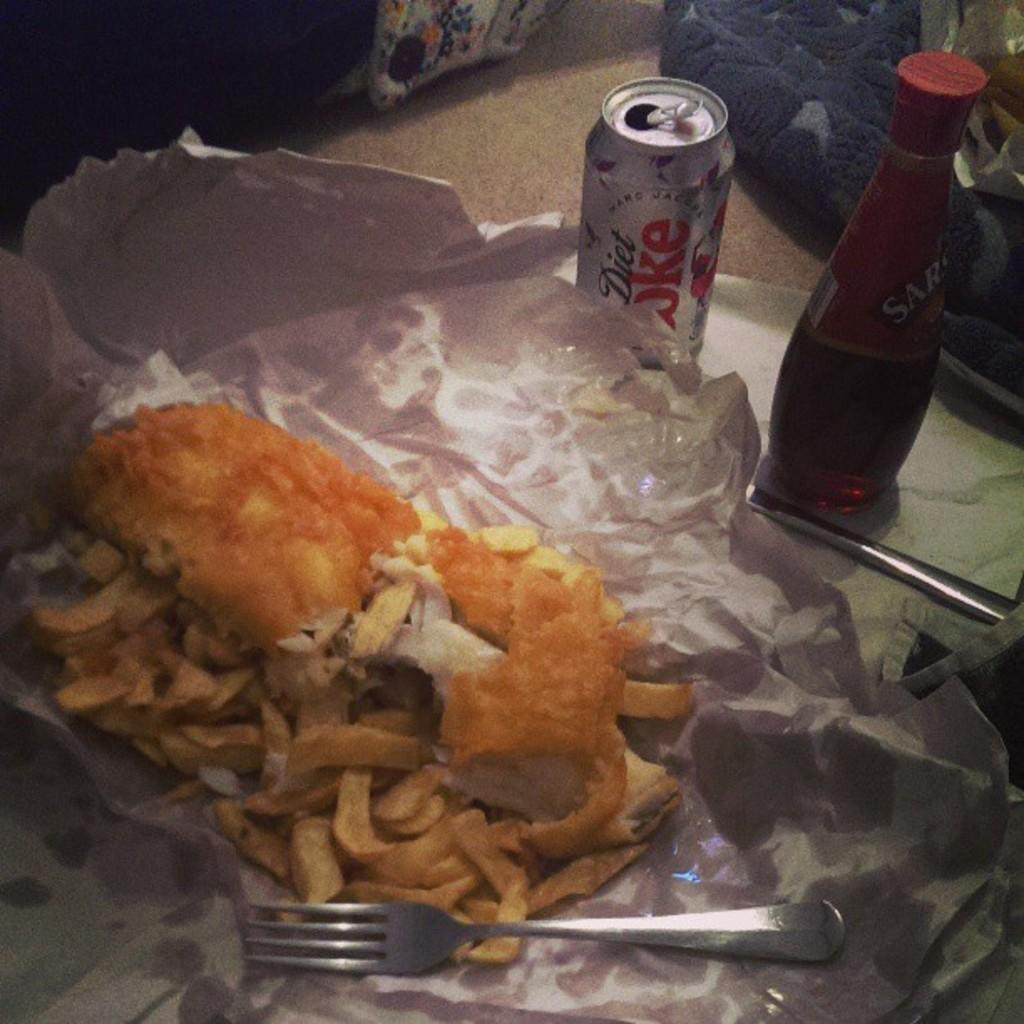<image>
Give a short and clear explanation of the subsequent image. good sitting in front of a can of diet coke 